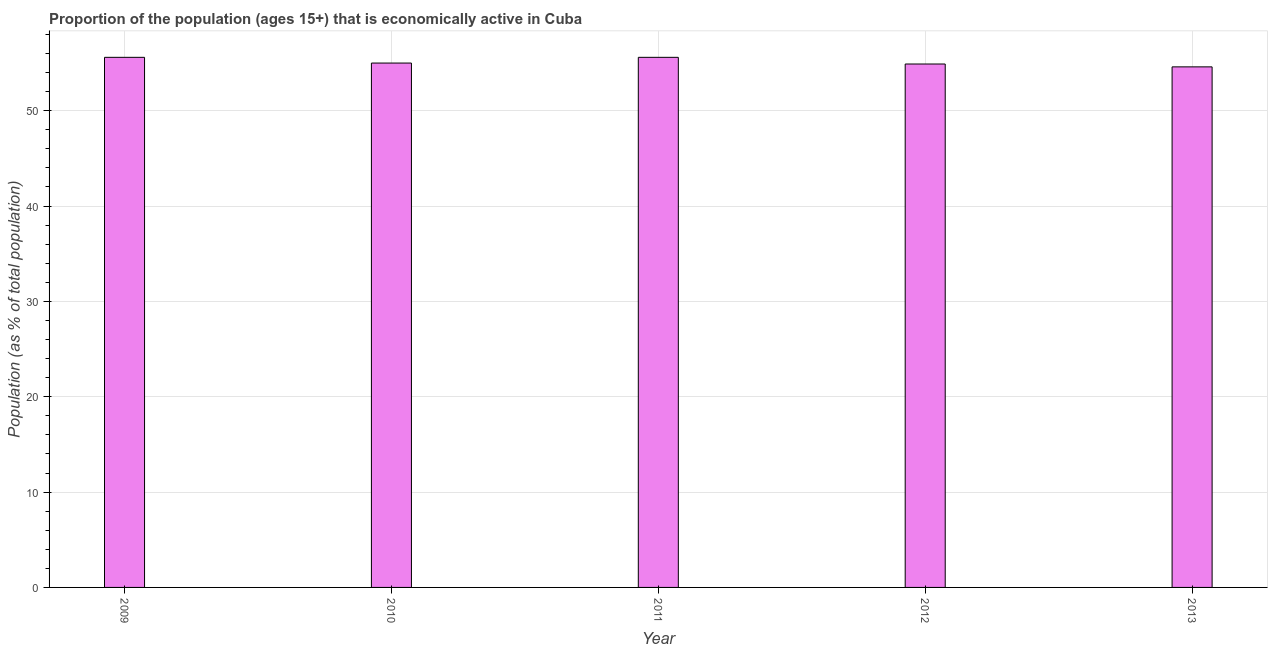What is the title of the graph?
Make the answer very short. Proportion of the population (ages 15+) that is economically active in Cuba. What is the label or title of the Y-axis?
Make the answer very short. Population (as % of total population). Across all years, what is the maximum percentage of economically active population?
Give a very brief answer. 55.6. Across all years, what is the minimum percentage of economically active population?
Offer a terse response. 54.6. In which year was the percentage of economically active population minimum?
Ensure brevity in your answer.  2013. What is the sum of the percentage of economically active population?
Make the answer very short. 275.7. What is the average percentage of economically active population per year?
Make the answer very short. 55.14. What is the median percentage of economically active population?
Your response must be concise. 55. In how many years, is the percentage of economically active population greater than 16 %?
Offer a very short reply. 5. Do a majority of the years between 2013 and 2012 (inclusive) have percentage of economically active population greater than 4 %?
Provide a succinct answer. No. What is the ratio of the percentage of economically active population in 2010 to that in 2013?
Give a very brief answer. 1.01. What is the difference between the highest and the second highest percentage of economically active population?
Keep it short and to the point. 0. What is the Population (as % of total population) of 2009?
Your answer should be very brief. 55.6. What is the Population (as % of total population) in 2010?
Your response must be concise. 55. What is the Population (as % of total population) of 2011?
Provide a succinct answer. 55.6. What is the Population (as % of total population) in 2012?
Keep it short and to the point. 54.9. What is the Population (as % of total population) in 2013?
Provide a short and direct response. 54.6. What is the difference between the Population (as % of total population) in 2009 and 2010?
Offer a very short reply. 0.6. What is the difference between the Population (as % of total population) in 2009 and 2011?
Provide a short and direct response. 0. What is the difference between the Population (as % of total population) in 2010 and 2011?
Your response must be concise. -0.6. What is the ratio of the Population (as % of total population) in 2009 to that in 2010?
Your response must be concise. 1.01. What is the ratio of the Population (as % of total population) in 2009 to that in 2013?
Give a very brief answer. 1.02. What is the ratio of the Population (as % of total population) in 2010 to that in 2011?
Your answer should be very brief. 0.99. What is the ratio of the Population (as % of total population) in 2010 to that in 2012?
Make the answer very short. 1. What is the ratio of the Population (as % of total population) in 2011 to that in 2013?
Your response must be concise. 1.02. What is the ratio of the Population (as % of total population) in 2012 to that in 2013?
Keep it short and to the point. 1. 